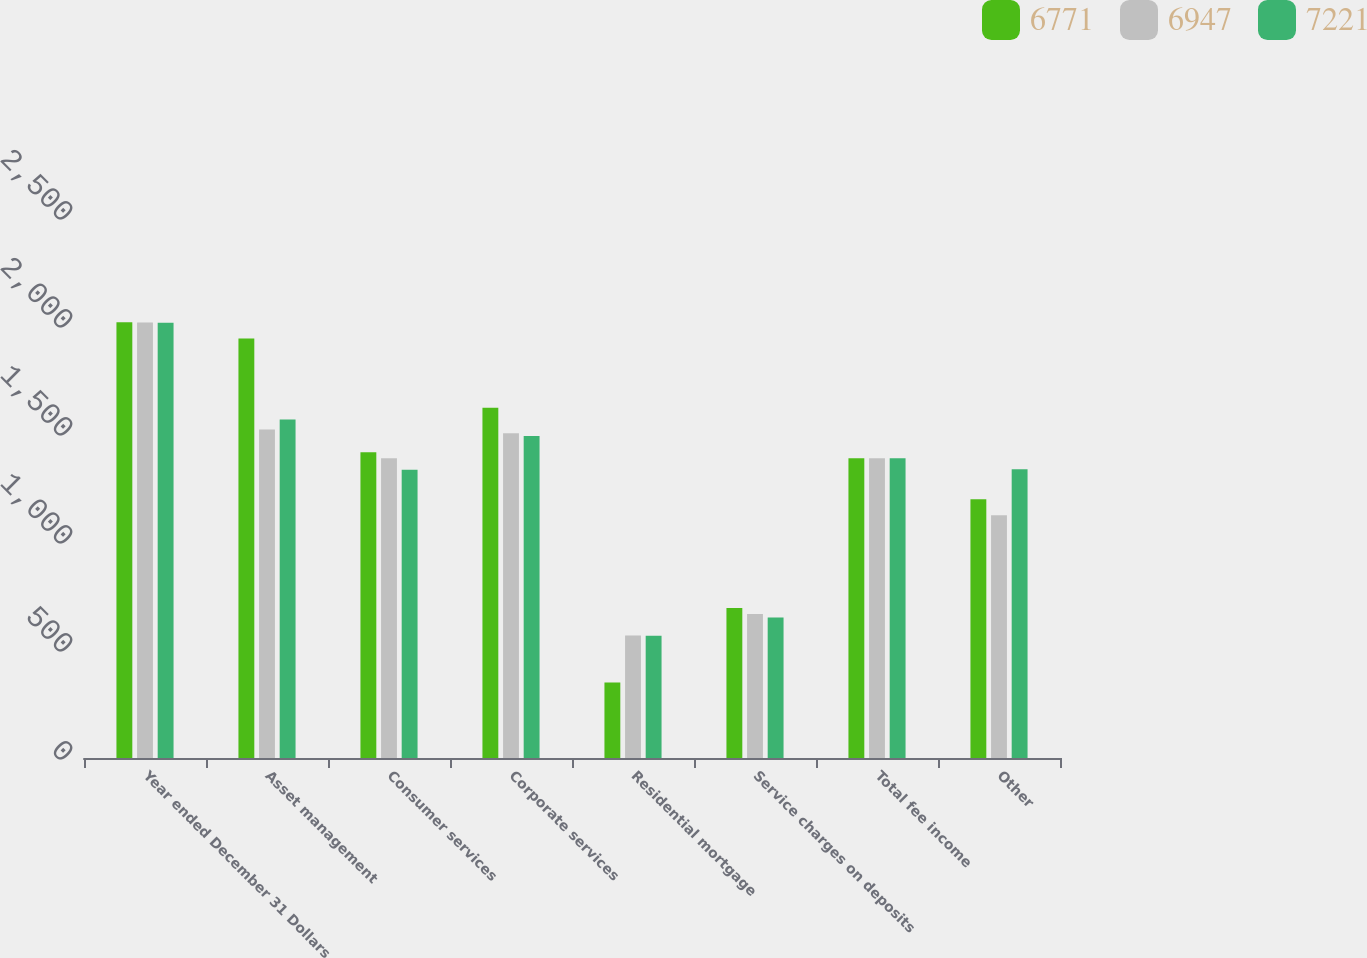Convert chart. <chart><loc_0><loc_0><loc_500><loc_500><stacked_bar_chart><ecel><fcel>Year ended December 31 Dollars<fcel>Asset management<fcel>Consumer services<fcel>Corporate services<fcel>Residential mortgage<fcel>Service charges on deposits<fcel>Total fee income<fcel>Other<nl><fcel>6771<fcel>2017<fcel>1942<fcel>1415<fcel>1621<fcel>350<fcel>695<fcel>1388<fcel>1198<nl><fcel>6947<fcel>2016<fcel>1521<fcel>1388<fcel>1504<fcel>567<fcel>667<fcel>1388<fcel>1124<nl><fcel>7221<fcel>2015<fcel>1567<fcel>1335<fcel>1491<fcel>566<fcel>651<fcel>1388<fcel>1337<nl></chart> 